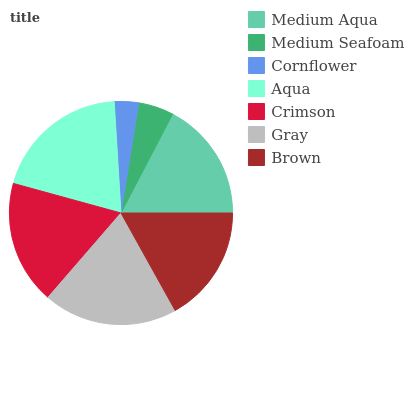Is Cornflower the minimum?
Answer yes or no. Yes. Is Aqua the maximum?
Answer yes or no. Yes. Is Medium Seafoam the minimum?
Answer yes or no. No. Is Medium Seafoam the maximum?
Answer yes or no. No. Is Medium Aqua greater than Medium Seafoam?
Answer yes or no. Yes. Is Medium Seafoam less than Medium Aqua?
Answer yes or no. Yes. Is Medium Seafoam greater than Medium Aqua?
Answer yes or no. No. Is Medium Aqua less than Medium Seafoam?
Answer yes or no. No. Is Medium Aqua the high median?
Answer yes or no. Yes. Is Medium Aqua the low median?
Answer yes or no. Yes. Is Medium Seafoam the high median?
Answer yes or no. No. Is Medium Seafoam the low median?
Answer yes or no. No. 